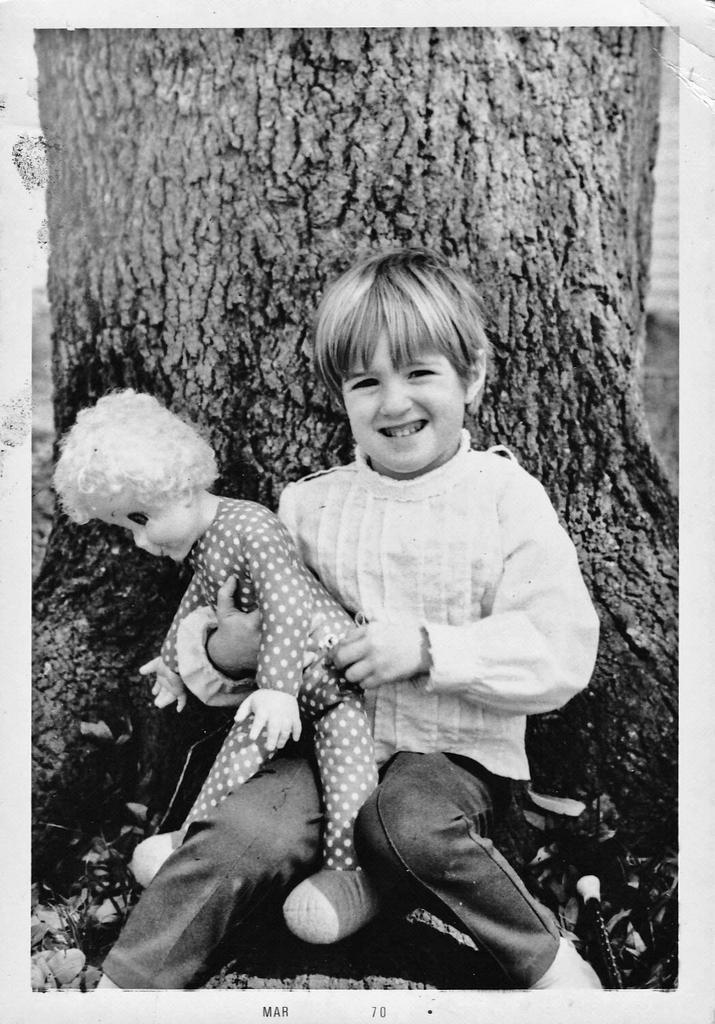Could you give a brief overview of what you see in this image? This is a black and white picture, in this image we can see a boy sitting and holding a toy, in the background, we can see a tree trunk. 